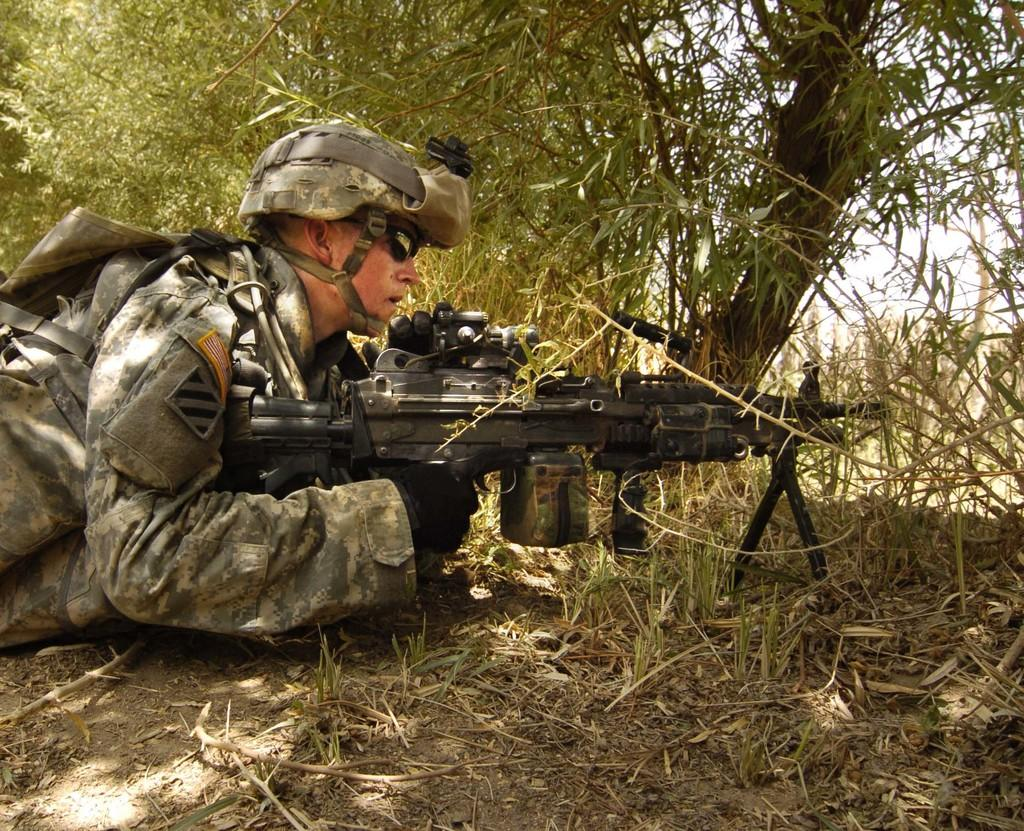What is the main subject of the image? The main subject of the image is an army man. What is the army man doing in the image? The army man is laying on the floor in the image. What is the army man holding in the image? The army man is holding a weapon in the image. What type of clothing is the army man wearing in the image? The army man is wearing an army dress and a cap in the image. What can be seen in the background of the image? There are trees visible in the background of the image. What type of feast is being prepared by the army man in the image? There is no indication of a feast being prepared in the image; the army man is laying on the floor and holding a weapon. Can you tell me how much sand is visible in the image? There is no sand visible in the image; it features an army man, trees, and a background with no sand. 